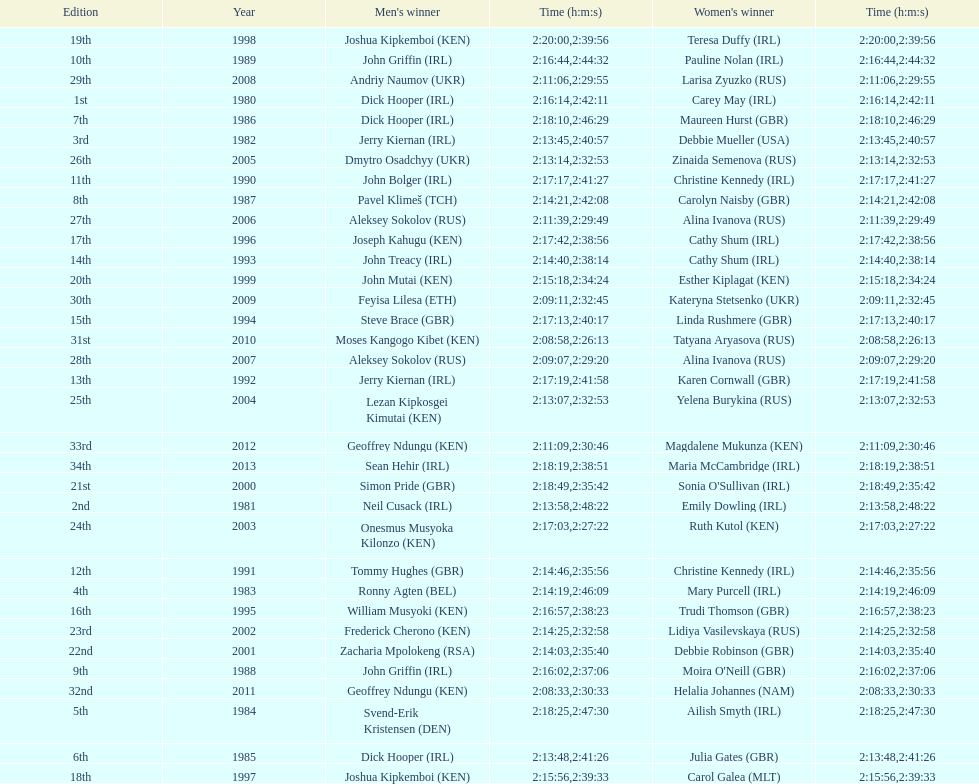In 2009, which competitor finished faster - the male or the female? Male. 